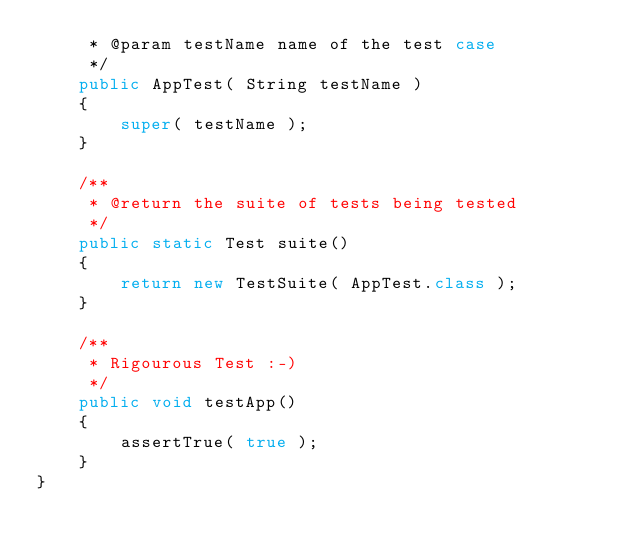Convert code to text. <code><loc_0><loc_0><loc_500><loc_500><_Java_>     * @param testName name of the test case
     */
    public AppTest( String testName )
    {
        super( testName );
    }

    /**
     * @return the suite of tests being tested
     */
    public static Test suite()
    {
        return new TestSuite( AppTest.class );
    }

    /**
     * Rigourous Test :-)
     */
    public void testApp()
    {
        assertTrue( true );
    }
}
</code> 